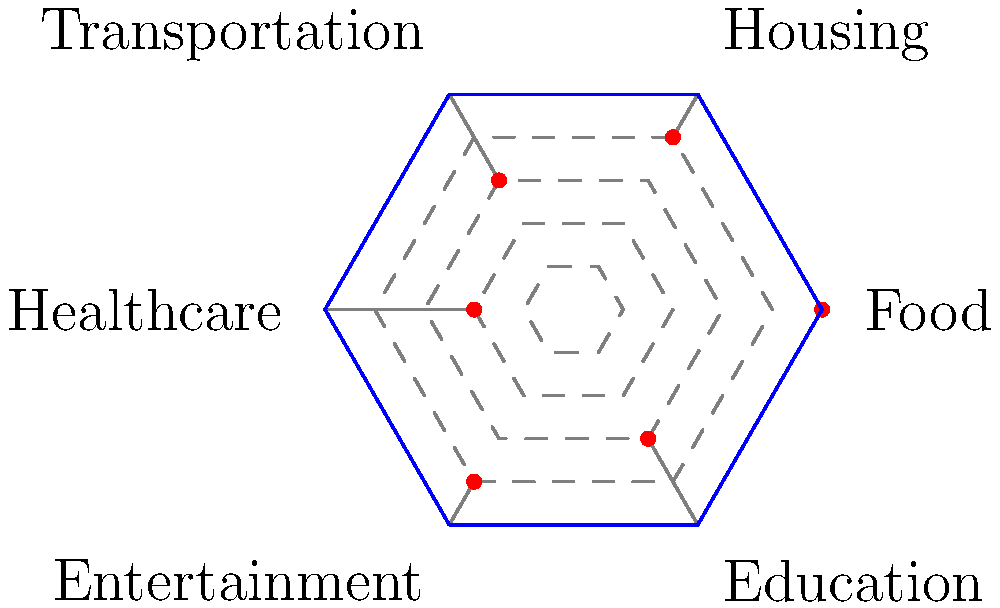The radar chart above represents consumer spending patterns across six categories. Each axis represents a spending category, with values from 1 (lowest) to 5 (highest). What is the total difference in spending between the two highest and two lowest spending categories? To solve this problem, we need to follow these steps:

1. Identify the spending levels for each category:
   Food: 5
   Housing: 4
   Transportation: 3
   Healthcare: 2
   Entertainment: 4
   Education: 3

2. Identify the two highest spending categories:
   Food (5) and Housing/Entertainment (both 4)

3. Identify the two lowest spending categories:
   Healthcare (2) and Transportation/Education (both 3)

4. Calculate the sum of the two highest categories:
   $5 + 4 = 9$

5. Calculate the sum of the two lowest categories:
   $2 + 3 = 5$

6. Calculate the difference between the sums:
   $9 - 5 = 4$

Therefore, the total difference in spending between the two highest and two lowest spending categories is 4.
Answer: 4 